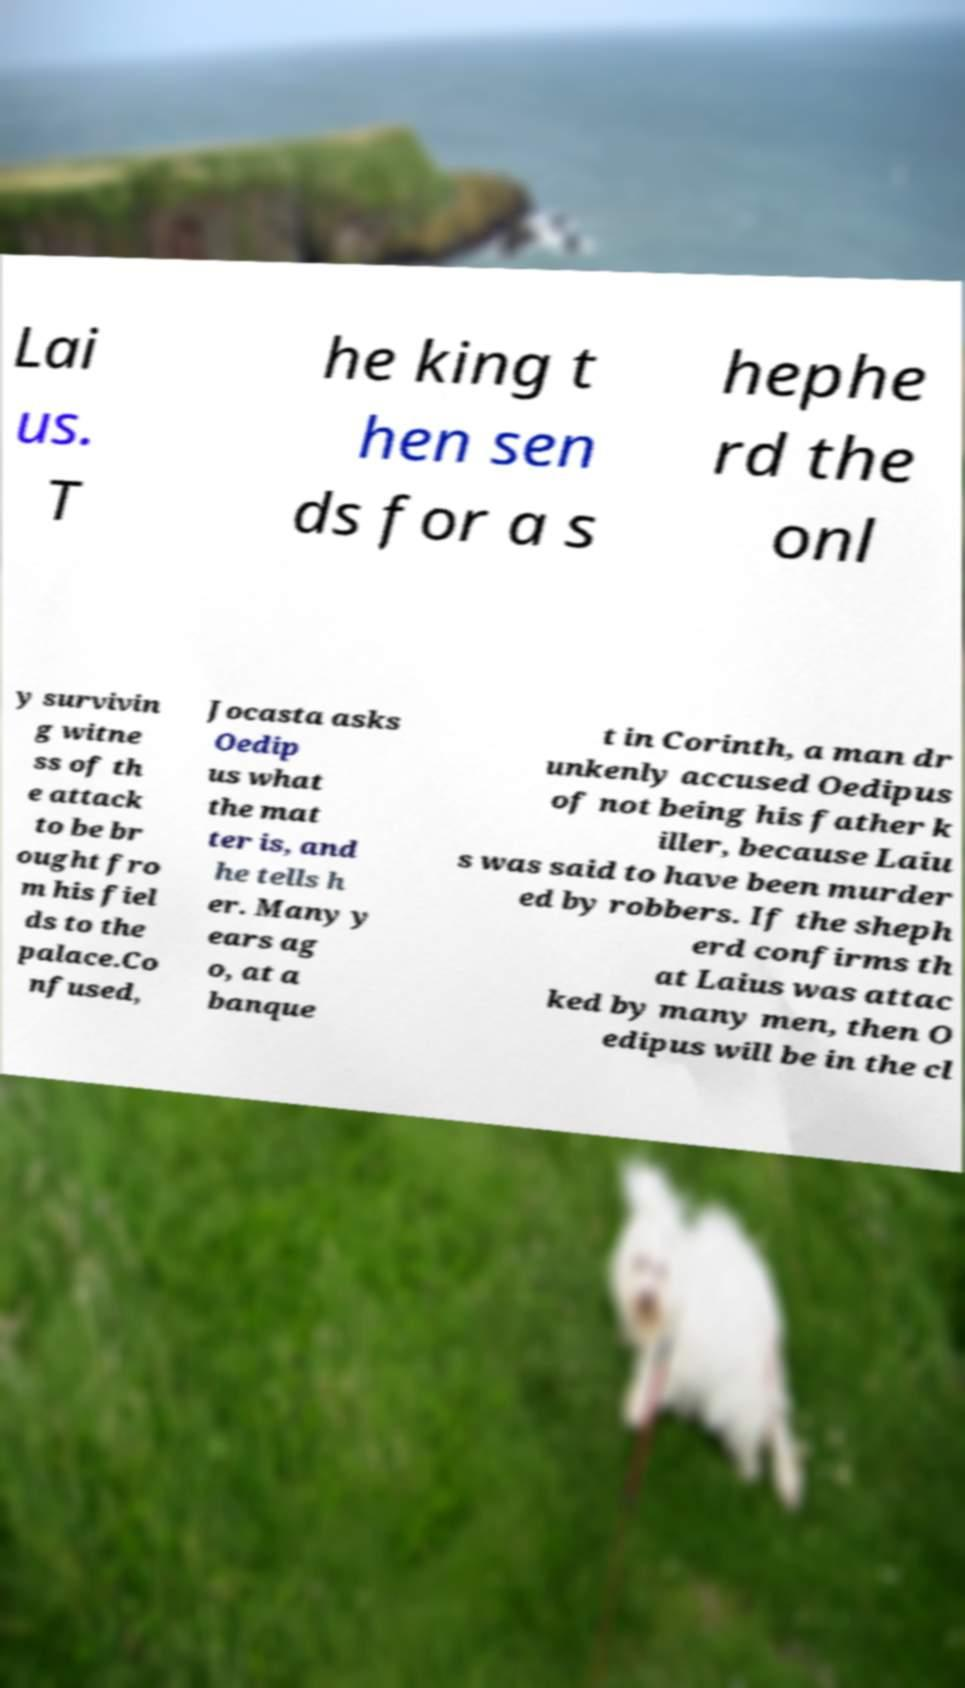I need the written content from this picture converted into text. Can you do that? Lai us. T he king t hen sen ds for a s hephe rd the onl y survivin g witne ss of th e attack to be br ought fro m his fiel ds to the palace.Co nfused, Jocasta asks Oedip us what the mat ter is, and he tells h er. Many y ears ag o, at a banque t in Corinth, a man dr unkenly accused Oedipus of not being his father k iller, because Laiu s was said to have been murder ed by robbers. If the sheph erd confirms th at Laius was attac ked by many men, then O edipus will be in the cl 